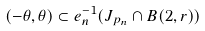<formula> <loc_0><loc_0><loc_500><loc_500>( - \theta , \theta ) \subset e _ { n } ^ { - 1 } ( J _ { p _ { n } } \cap B ( 2 , r ) )</formula> 